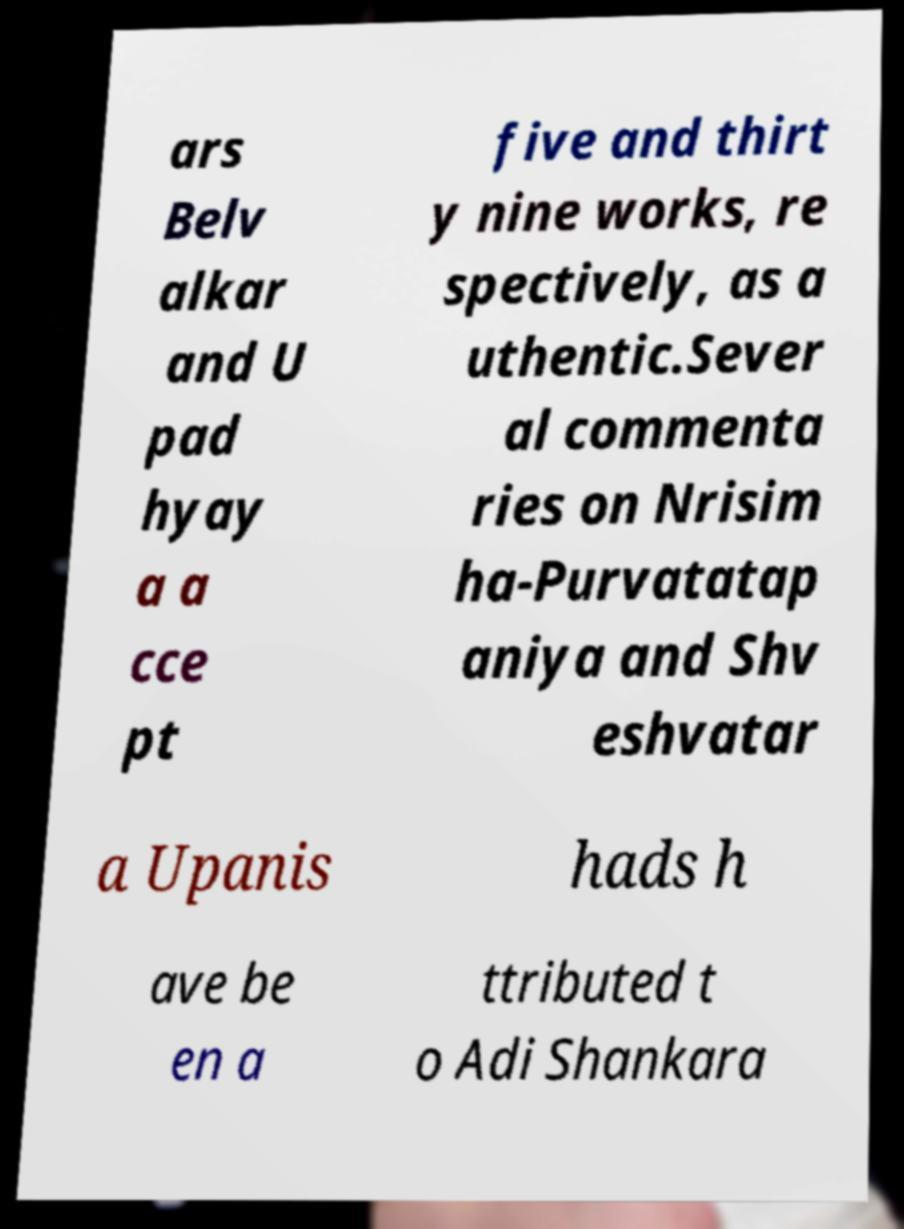What messages or text are displayed in this image? I need them in a readable, typed format. ars Belv alkar and U pad hyay a a cce pt five and thirt y nine works, re spectively, as a uthentic.Sever al commenta ries on Nrisim ha-Purvatatap aniya and Shv eshvatar a Upanis hads h ave be en a ttributed t o Adi Shankara 